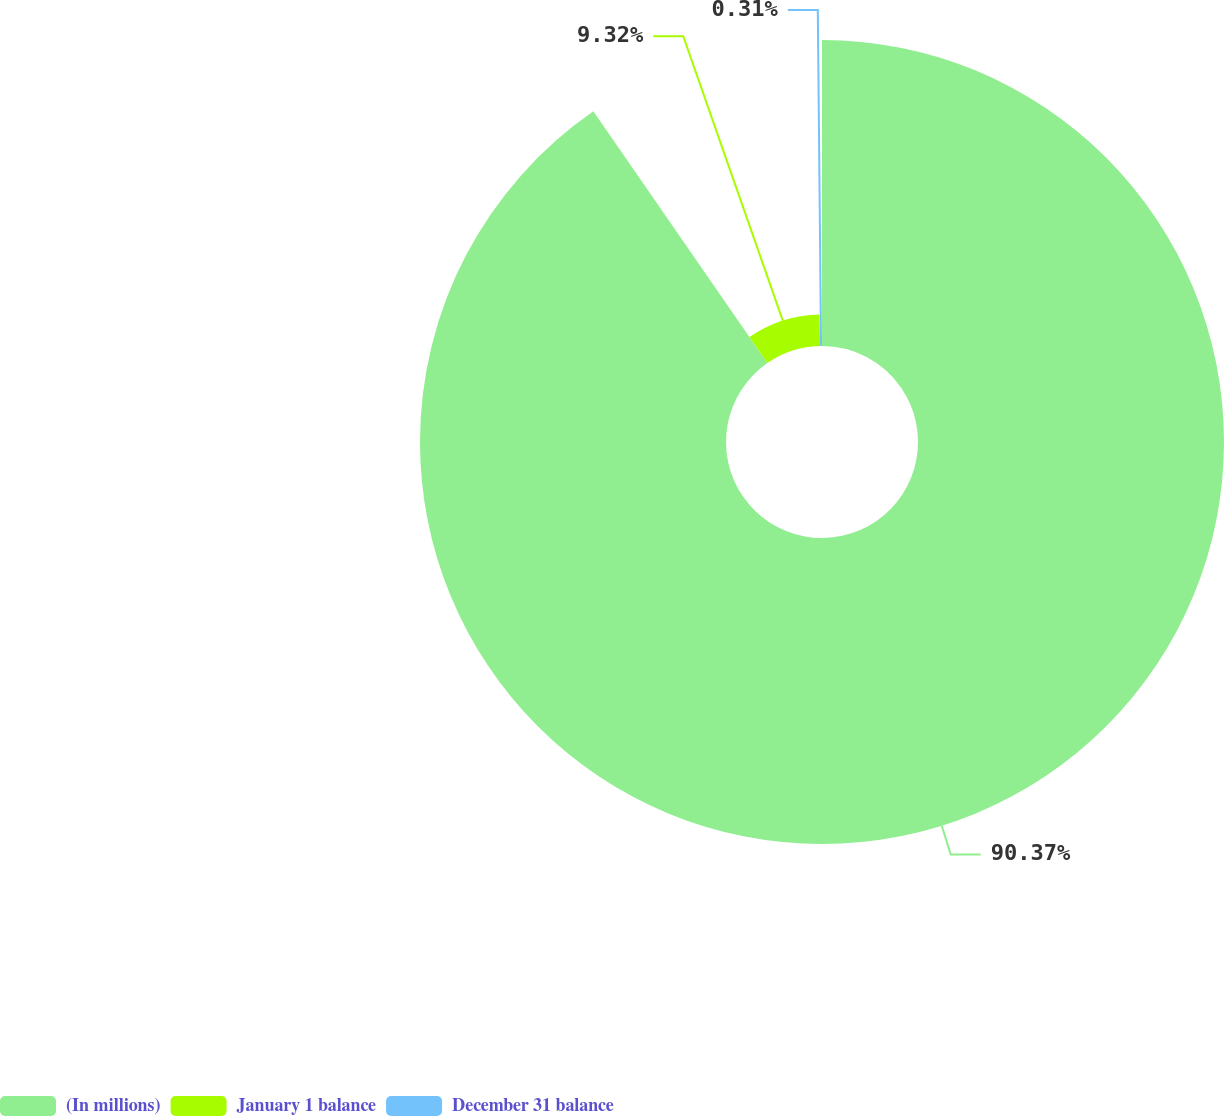Convert chart. <chart><loc_0><loc_0><loc_500><loc_500><pie_chart><fcel>(In millions)<fcel>January 1 balance<fcel>December 31 balance<nl><fcel>90.37%<fcel>9.32%<fcel>0.31%<nl></chart> 